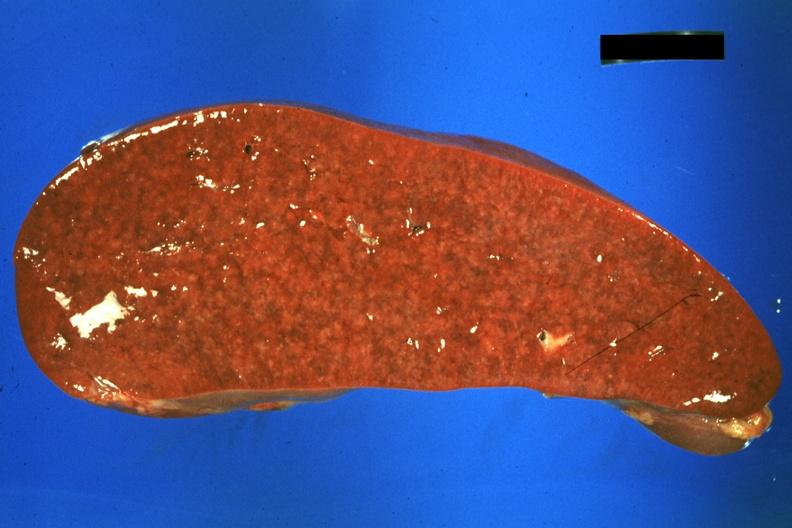s endometritis present?
Answer the question using a single word or phrase. No 